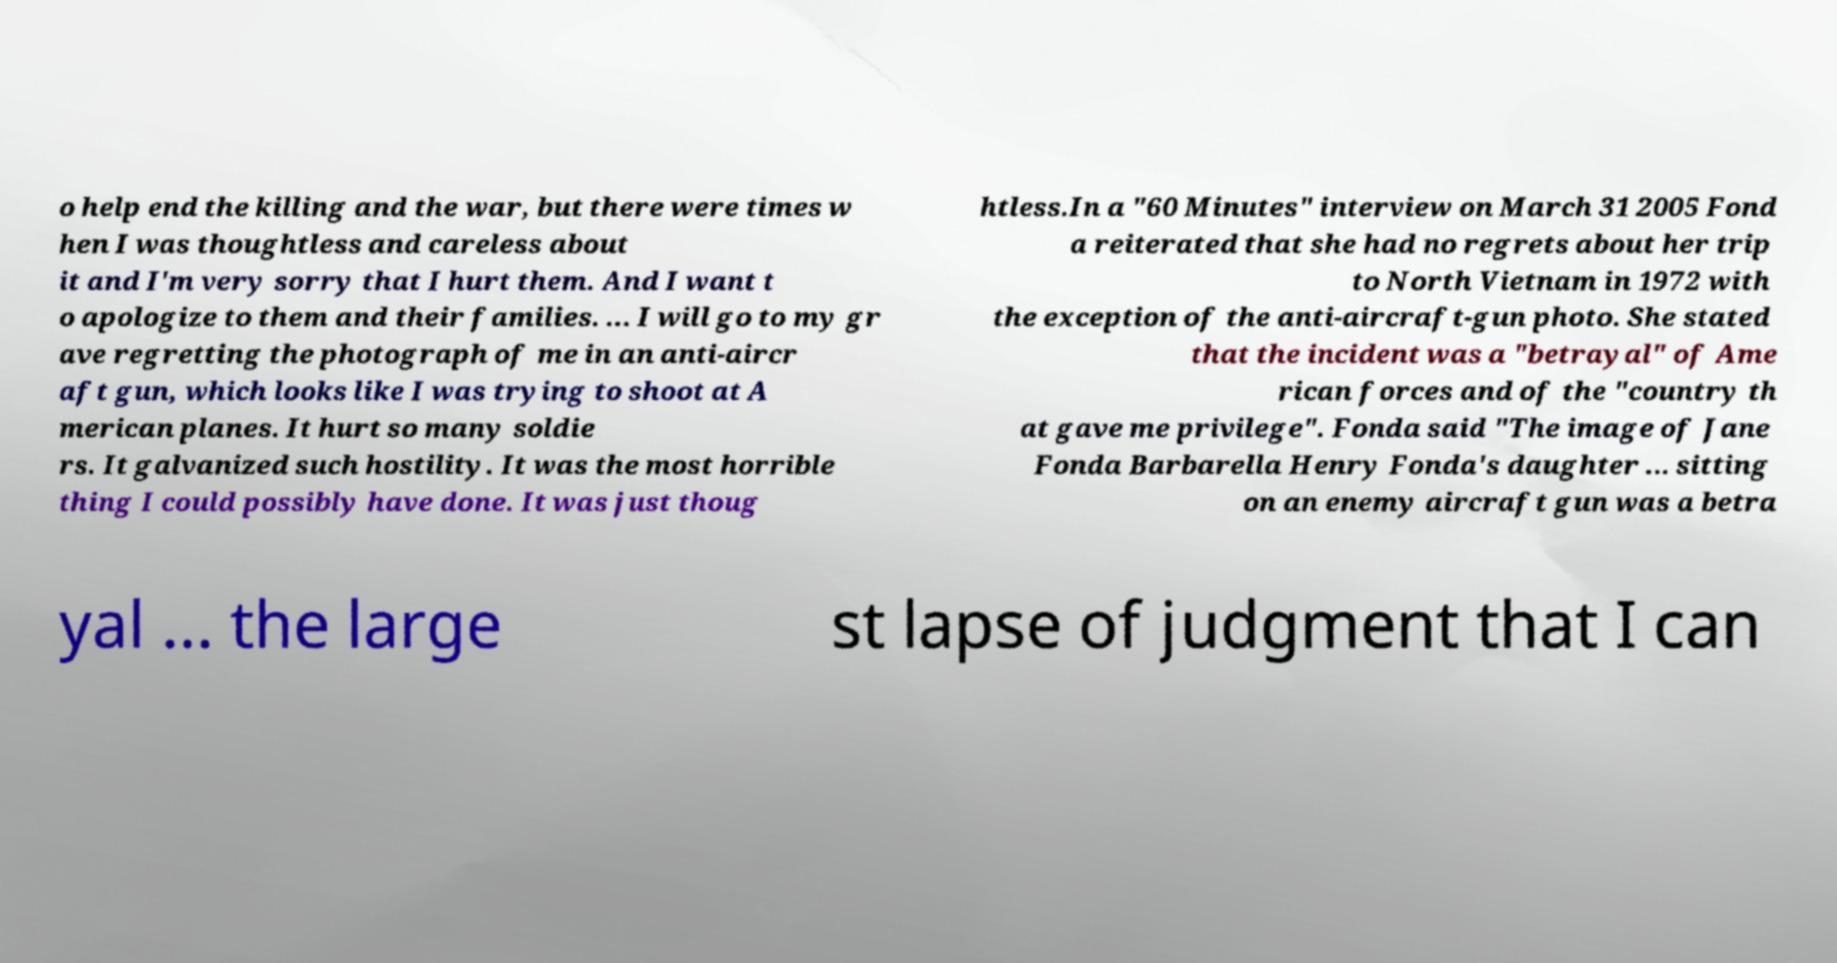For documentation purposes, I need the text within this image transcribed. Could you provide that? o help end the killing and the war, but there were times w hen I was thoughtless and careless about it and I'm very sorry that I hurt them. And I want t o apologize to them and their families. ... I will go to my gr ave regretting the photograph of me in an anti-aircr aft gun, which looks like I was trying to shoot at A merican planes. It hurt so many soldie rs. It galvanized such hostility. It was the most horrible thing I could possibly have done. It was just thoug htless.In a "60 Minutes" interview on March 31 2005 Fond a reiterated that she had no regrets about her trip to North Vietnam in 1972 with the exception of the anti-aircraft-gun photo. She stated that the incident was a "betrayal" of Ame rican forces and of the "country th at gave me privilege". Fonda said "The image of Jane Fonda Barbarella Henry Fonda's daughter ... sitting on an enemy aircraft gun was a betra yal ... the large st lapse of judgment that I can 